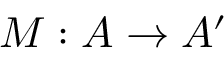Convert formula to latex. <formula><loc_0><loc_0><loc_500><loc_500>M \colon A \rightarrow A ^ { \prime }</formula> 